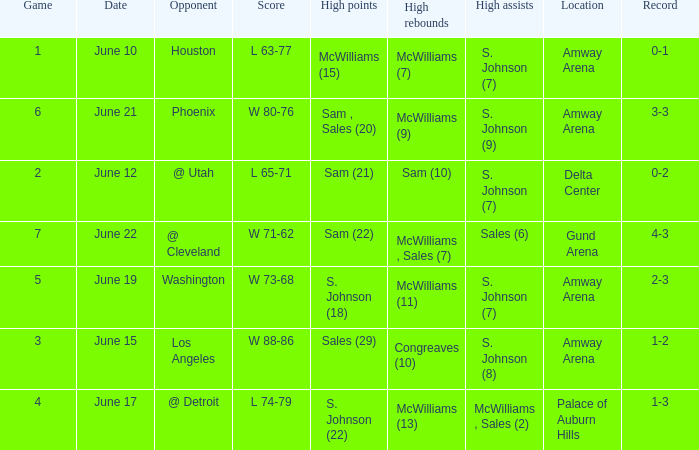Name the total number of date for  l 63-77 1.0. 